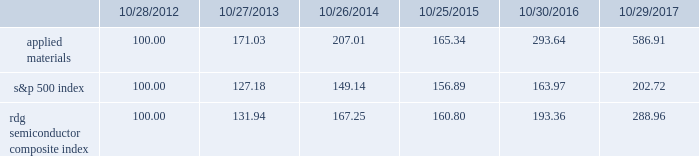Performance graph the performance graph below shows the five-year cumulative total stockholder return on applied common stock during the period from october 28 , 2012 through october 29 , 2017 .
This is compared with the cumulative total return of the standard & poor 2019s 500 stock index and the rdg semiconductor composite index over the same period .
The comparison assumes $ 100 was invested on october 28 , 2012 in applied common stock and in each of the foregoing indices and assumes reinvestment of dividends , if any .
Dollar amounts in the graph are rounded to the nearest whole dollar .
The performance shown in the graph represents past performance and should not be considered an indication of future performance .
Comparison of 5 year cumulative total return* among applied materials , inc. , the s&p 500 index and the rdg semiconductor composite index *assumes $ 100 invested on 10/28/12 in stock or 10/31/12 in index , including reinvestment of dividends .
Indexes calculated on month-end basis .
Copyright a9 2017 standard & poor 2019s , a division of s&p global .
All rights reserved. .
Dividends during each of fiscal 2017 , 2016 and 2015 , applied 2019s board of directors declared four quarterly cash dividends in the amount of $ 0.10 per share .
Applied currently anticipates that cash dividends will continue to be paid on a quarterly basis , although the declaration of any future cash dividend is at the discretion of the board of directors and will depend on applied 2019s financial condition , results of operations , capital requirements , business conditions and other factors , as well as a determination by the board of directors that cash dividends are in the best interests of applied 2019s stockholders .
10/28/12 10/27/13 10/26/14 10/25/15 10/30/16 10/29/17 applied materials , inc .
S&p 500 rdg semiconductor composite .
What is the roi in s&p500 if the investment was made in 2012 and sold in 2015? 
Computations: ((156.89 - 100) / 100)
Answer: 0.5689. 